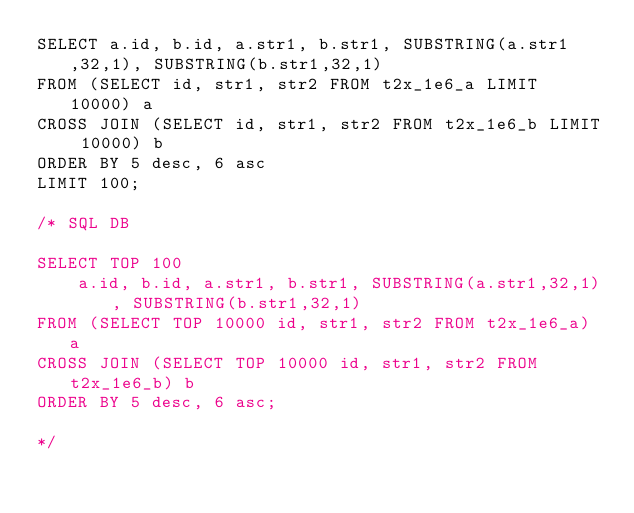Convert code to text. <code><loc_0><loc_0><loc_500><loc_500><_SQL_>SELECT a.id, b.id, a.str1, b.str1, SUBSTRING(a.str1,32,1), SUBSTRING(b.str1,32,1)
FROM (SELECT id, str1, str2 FROM t2x_1e6_a LIMIT 10000) a 
CROSS JOIN (SELECT id, str1, str2 FROM t2x_1e6_b LIMIT 10000) b 
ORDER BY 5 desc, 6 asc
LIMIT 100;

/* SQL DB 

SELECT TOP 100 
    a.id, b.id, a.str1, b.str1, SUBSTRING(a.str1,32,1), SUBSTRING(b.str1,32,1)
FROM (SELECT TOP 10000 id, str1, str2 FROM t2x_1e6_a) a 
CROSS JOIN (SELECT TOP 10000 id, str1, str2 FROM t2x_1e6_b) b 
ORDER BY 5 desc, 6 asc;

*/</code> 